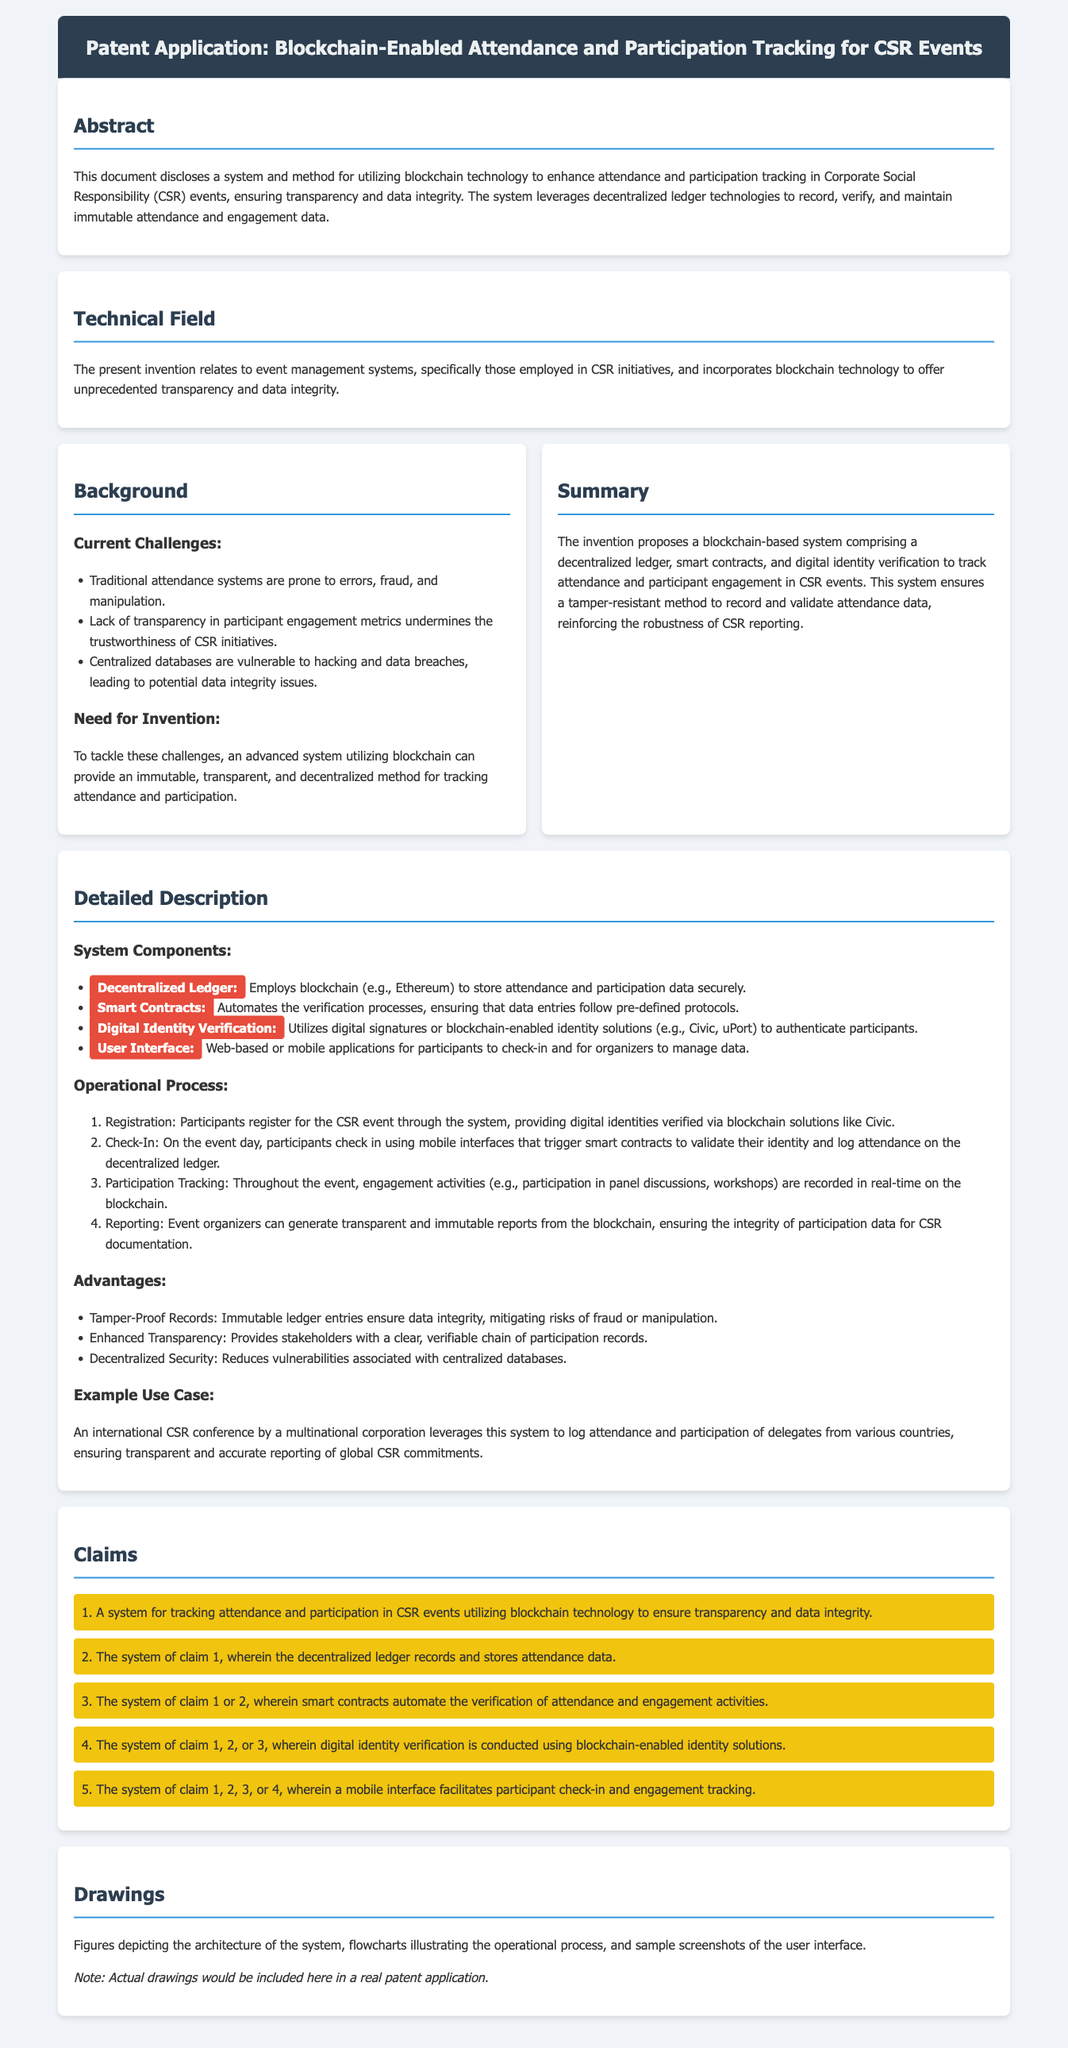What is the main technology employed in the invention? The main technology employed is blockchain to enhance attendance and participation tracking.
Answer: blockchain What are the key components of the system? Key components include a decentralized ledger, smart contracts, digital identity verification, and a user interface.
Answer: decentralized ledger, smart contracts, digital identity verification, user interface What is one of the current challenges mentioned in the document? One of the current challenges is the lack of transparency in participant engagement metrics.
Answer: lack of transparency in participant engagement metrics What operational process is used for participant check-in? Participants check in using mobile interfaces that trigger smart contracts to validate their identity.
Answer: mobile interfaces that trigger smart contracts How many claims are presented in the document? The document presents a total of five claims regarding the system for tracking attendance and participation.
Answer: five claims Which specific application is highlighted as an example use case? The example use case highlighted is an international CSR conference by a multinational corporation.
Answer: international CSR conference by a multinational corporation What advantage does the system provide in terms of data integrity? The system provides tamper-proof records to ensure data integrity.
Answer: tamper-proof records In what manner does the system enhance transparency? The system enhances transparency by providing stakeholders with a clear, verifiable chain of participation records.
Answer: clear, verifiable chain of participation records What is the purpose of digital identity verification in the system? The purpose is to authenticate participants using blockchain-enabled identity solutions.
Answer: authenticate participants using blockchain-enabled identity solutions 